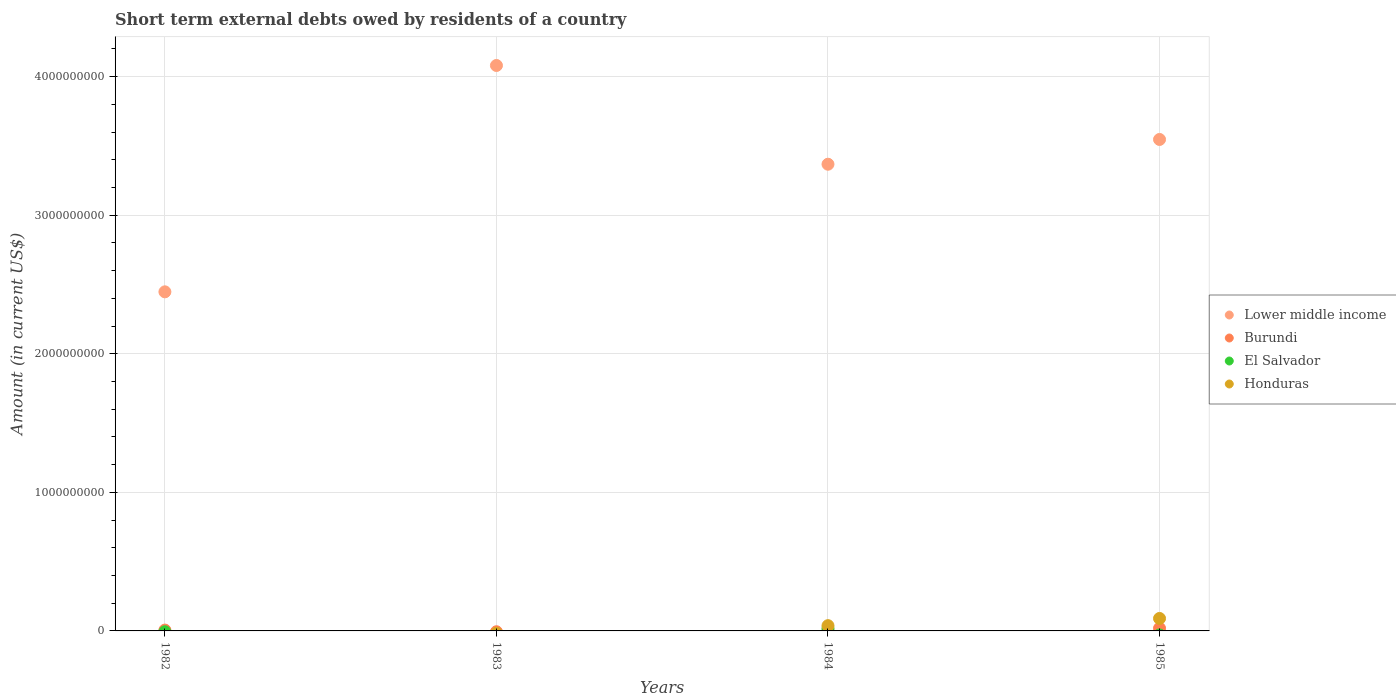Across all years, what is the maximum amount of short-term external debts owed by residents in El Salvador?
Ensure brevity in your answer.  1.70e+07. What is the total amount of short-term external debts owed by residents in Honduras in the graph?
Offer a terse response. 1.28e+08. What is the difference between the amount of short-term external debts owed by residents in Lower middle income in 1982 and that in 1985?
Give a very brief answer. -1.10e+09. What is the difference between the amount of short-term external debts owed by residents in Burundi in 1985 and the amount of short-term external debts owed by residents in El Salvador in 1984?
Provide a short and direct response. 2.00e+06. What is the average amount of short-term external debts owed by residents in Honduras per year?
Offer a very short reply. 3.20e+07. In the year 1982, what is the difference between the amount of short-term external debts owed by residents in Burundi and amount of short-term external debts owed by residents in Lower middle income?
Offer a very short reply. -2.44e+09. In how many years, is the amount of short-term external debts owed by residents in Lower middle income greater than 1400000000 US$?
Provide a short and direct response. 4. What is the ratio of the amount of short-term external debts owed by residents in Honduras in 1984 to that in 1985?
Offer a terse response. 0.42. Is the amount of short-term external debts owed by residents in Burundi in 1984 less than that in 1985?
Keep it short and to the point. Yes. What is the difference between the highest and the second highest amount of short-term external debts owed by residents in Lower middle income?
Your response must be concise. 5.34e+08. What is the difference between the highest and the lowest amount of short-term external debts owed by residents in Honduras?
Your answer should be compact. 9.00e+07. Is the sum of the amount of short-term external debts owed by residents in Lower middle income in 1983 and 1984 greater than the maximum amount of short-term external debts owed by residents in Burundi across all years?
Give a very brief answer. Yes. Is it the case that in every year, the sum of the amount of short-term external debts owed by residents in Lower middle income and amount of short-term external debts owed by residents in Honduras  is greater than the sum of amount of short-term external debts owed by residents in El Salvador and amount of short-term external debts owed by residents in Burundi?
Provide a succinct answer. No. Is it the case that in every year, the sum of the amount of short-term external debts owed by residents in Lower middle income and amount of short-term external debts owed by residents in Burundi  is greater than the amount of short-term external debts owed by residents in Honduras?
Make the answer very short. Yes. Are the values on the major ticks of Y-axis written in scientific E-notation?
Offer a terse response. No. Does the graph contain any zero values?
Keep it short and to the point. Yes. Where does the legend appear in the graph?
Provide a succinct answer. Center right. How many legend labels are there?
Keep it short and to the point. 4. What is the title of the graph?
Keep it short and to the point. Short term external debts owed by residents of a country. What is the label or title of the X-axis?
Provide a short and direct response. Years. What is the Amount (in current US$) in Lower middle income in 1982?
Offer a very short reply. 2.45e+09. What is the Amount (in current US$) of El Salvador in 1982?
Make the answer very short. 0. What is the Amount (in current US$) in Honduras in 1982?
Keep it short and to the point. 0. What is the Amount (in current US$) in Lower middle income in 1983?
Provide a short and direct response. 4.08e+09. What is the Amount (in current US$) in Burundi in 1983?
Provide a short and direct response. 0. What is the Amount (in current US$) of El Salvador in 1983?
Give a very brief answer. 0. What is the Amount (in current US$) of Lower middle income in 1984?
Your answer should be compact. 3.37e+09. What is the Amount (in current US$) of El Salvador in 1984?
Make the answer very short. 1.70e+07. What is the Amount (in current US$) in Honduras in 1984?
Ensure brevity in your answer.  3.80e+07. What is the Amount (in current US$) in Lower middle income in 1985?
Offer a very short reply. 3.55e+09. What is the Amount (in current US$) of Burundi in 1985?
Your answer should be compact. 1.90e+07. What is the Amount (in current US$) of Honduras in 1985?
Make the answer very short. 9.00e+07. Across all years, what is the maximum Amount (in current US$) in Lower middle income?
Give a very brief answer. 4.08e+09. Across all years, what is the maximum Amount (in current US$) of Burundi?
Your answer should be compact. 1.90e+07. Across all years, what is the maximum Amount (in current US$) of El Salvador?
Offer a terse response. 1.70e+07. Across all years, what is the maximum Amount (in current US$) in Honduras?
Ensure brevity in your answer.  9.00e+07. Across all years, what is the minimum Amount (in current US$) in Lower middle income?
Your answer should be very brief. 2.45e+09. Across all years, what is the minimum Amount (in current US$) in Burundi?
Provide a short and direct response. 0. What is the total Amount (in current US$) of Lower middle income in the graph?
Your answer should be compact. 1.34e+1. What is the total Amount (in current US$) of Burundi in the graph?
Your response must be concise. 2.70e+07. What is the total Amount (in current US$) in El Salvador in the graph?
Offer a very short reply. 1.70e+07. What is the total Amount (in current US$) of Honduras in the graph?
Give a very brief answer. 1.28e+08. What is the difference between the Amount (in current US$) of Lower middle income in 1982 and that in 1983?
Ensure brevity in your answer.  -1.63e+09. What is the difference between the Amount (in current US$) in Lower middle income in 1982 and that in 1984?
Your answer should be compact. -9.21e+08. What is the difference between the Amount (in current US$) in Lower middle income in 1982 and that in 1985?
Offer a very short reply. -1.10e+09. What is the difference between the Amount (in current US$) of Burundi in 1982 and that in 1985?
Offer a very short reply. -1.30e+07. What is the difference between the Amount (in current US$) in Lower middle income in 1983 and that in 1984?
Make the answer very short. 7.13e+08. What is the difference between the Amount (in current US$) of Lower middle income in 1983 and that in 1985?
Provide a succinct answer. 5.34e+08. What is the difference between the Amount (in current US$) in Lower middle income in 1984 and that in 1985?
Your response must be concise. -1.79e+08. What is the difference between the Amount (in current US$) of Burundi in 1984 and that in 1985?
Offer a terse response. -1.70e+07. What is the difference between the Amount (in current US$) of Honduras in 1984 and that in 1985?
Your answer should be very brief. -5.20e+07. What is the difference between the Amount (in current US$) of Lower middle income in 1982 and the Amount (in current US$) of Burundi in 1984?
Keep it short and to the point. 2.45e+09. What is the difference between the Amount (in current US$) of Lower middle income in 1982 and the Amount (in current US$) of El Salvador in 1984?
Ensure brevity in your answer.  2.43e+09. What is the difference between the Amount (in current US$) of Lower middle income in 1982 and the Amount (in current US$) of Honduras in 1984?
Your answer should be compact. 2.41e+09. What is the difference between the Amount (in current US$) of Burundi in 1982 and the Amount (in current US$) of El Salvador in 1984?
Keep it short and to the point. -1.10e+07. What is the difference between the Amount (in current US$) of Burundi in 1982 and the Amount (in current US$) of Honduras in 1984?
Your answer should be compact. -3.20e+07. What is the difference between the Amount (in current US$) in Lower middle income in 1982 and the Amount (in current US$) in Burundi in 1985?
Offer a very short reply. 2.43e+09. What is the difference between the Amount (in current US$) in Lower middle income in 1982 and the Amount (in current US$) in Honduras in 1985?
Your response must be concise. 2.36e+09. What is the difference between the Amount (in current US$) of Burundi in 1982 and the Amount (in current US$) of Honduras in 1985?
Your answer should be compact. -8.40e+07. What is the difference between the Amount (in current US$) in Lower middle income in 1983 and the Amount (in current US$) in Burundi in 1984?
Make the answer very short. 4.08e+09. What is the difference between the Amount (in current US$) of Lower middle income in 1983 and the Amount (in current US$) of El Salvador in 1984?
Your response must be concise. 4.06e+09. What is the difference between the Amount (in current US$) of Lower middle income in 1983 and the Amount (in current US$) of Honduras in 1984?
Keep it short and to the point. 4.04e+09. What is the difference between the Amount (in current US$) of Lower middle income in 1983 and the Amount (in current US$) of Burundi in 1985?
Keep it short and to the point. 4.06e+09. What is the difference between the Amount (in current US$) in Lower middle income in 1983 and the Amount (in current US$) in Honduras in 1985?
Your response must be concise. 3.99e+09. What is the difference between the Amount (in current US$) of Lower middle income in 1984 and the Amount (in current US$) of Burundi in 1985?
Your answer should be compact. 3.35e+09. What is the difference between the Amount (in current US$) of Lower middle income in 1984 and the Amount (in current US$) of Honduras in 1985?
Ensure brevity in your answer.  3.28e+09. What is the difference between the Amount (in current US$) in Burundi in 1984 and the Amount (in current US$) in Honduras in 1985?
Ensure brevity in your answer.  -8.80e+07. What is the difference between the Amount (in current US$) of El Salvador in 1984 and the Amount (in current US$) of Honduras in 1985?
Keep it short and to the point. -7.30e+07. What is the average Amount (in current US$) of Lower middle income per year?
Ensure brevity in your answer.  3.36e+09. What is the average Amount (in current US$) of Burundi per year?
Your answer should be compact. 6.75e+06. What is the average Amount (in current US$) in El Salvador per year?
Provide a succinct answer. 4.25e+06. What is the average Amount (in current US$) of Honduras per year?
Provide a succinct answer. 3.20e+07. In the year 1982, what is the difference between the Amount (in current US$) in Lower middle income and Amount (in current US$) in Burundi?
Ensure brevity in your answer.  2.44e+09. In the year 1984, what is the difference between the Amount (in current US$) of Lower middle income and Amount (in current US$) of Burundi?
Your response must be concise. 3.37e+09. In the year 1984, what is the difference between the Amount (in current US$) of Lower middle income and Amount (in current US$) of El Salvador?
Offer a terse response. 3.35e+09. In the year 1984, what is the difference between the Amount (in current US$) of Lower middle income and Amount (in current US$) of Honduras?
Keep it short and to the point. 3.33e+09. In the year 1984, what is the difference between the Amount (in current US$) of Burundi and Amount (in current US$) of El Salvador?
Ensure brevity in your answer.  -1.50e+07. In the year 1984, what is the difference between the Amount (in current US$) of Burundi and Amount (in current US$) of Honduras?
Keep it short and to the point. -3.60e+07. In the year 1984, what is the difference between the Amount (in current US$) of El Salvador and Amount (in current US$) of Honduras?
Offer a very short reply. -2.10e+07. In the year 1985, what is the difference between the Amount (in current US$) in Lower middle income and Amount (in current US$) in Burundi?
Ensure brevity in your answer.  3.53e+09. In the year 1985, what is the difference between the Amount (in current US$) of Lower middle income and Amount (in current US$) of Honduras?
Your answer should be compact. 3.46e+09. In the year 1985, what is the difference between the Amount (in current US$) of Burundi and Amount (in current US$) of Honduras?
Offer a terse response. -7.10e+07. What is the ratio of the Amount (in current US$) in Lower middle income in 1982 to that in 1983?
Make the answer very short. 0.6. What is the ratio of the Amount (in current US$) in Lower middle income in 1982 to that in 1984?
Offer a very short reply. 0.73. What is the ratio of the Amount (in current US$) in Lower middle income in 1982 to that in 1985?
Your answer should be compact. 0.69. What is the ratio of the Amount (in current US$) of Burundi in 1982 to that in 1985?
Make the answer very short. 0.32. What is the ratio of the Amount (in current US$) of Lower middle income in 1983 to that in 1984?
Your answer should be very brief. 1.21. What is the ratio of the Amount (in current US$) of Lower middle income in 1983 to that in 1985?
Offer a terse response. 1.15. What is the ratio of the Amount (in current US$) in Lower middle income in 1984 to that in 1985?
Provide a short and direct response. 0.95. What is the ratio of the Amount (in current US$) of Burundi in 1984 to that in 1985?
Ensure brevity in your answer.  0.11. What is the ratio of the Amount (in current US$) of Honduras in 1984 to that in 1985?
Offer a terse response. 0.42. What is the difference between the highest and the second highest Amount (in current US$) in Lower middle income?
Provide a succinct answer. 5.34e+08. What is the difference between the highest and the second highest Amount (in current US$) in Burundi?
Provide a succinct answer. 1.30e+07. What is the difference between the highest and the lowest Amount (in current US$) of Lower middle income?
Ensure brevity in your answer.  1.63e+09. What is the difference between the highest and the lowest Amount (in current US$) in Burundi?
Your response must be concise. 1.90e+07. What is the difference between the highest and the lowest Amount (in current US$) in El Salvador?
Ensure brevity in your answer.  1.70e+07. What is the difference between the highest and the lowest Amount (in current US$) in Honduras?
Your answer should be compact. 9.00e+07. 